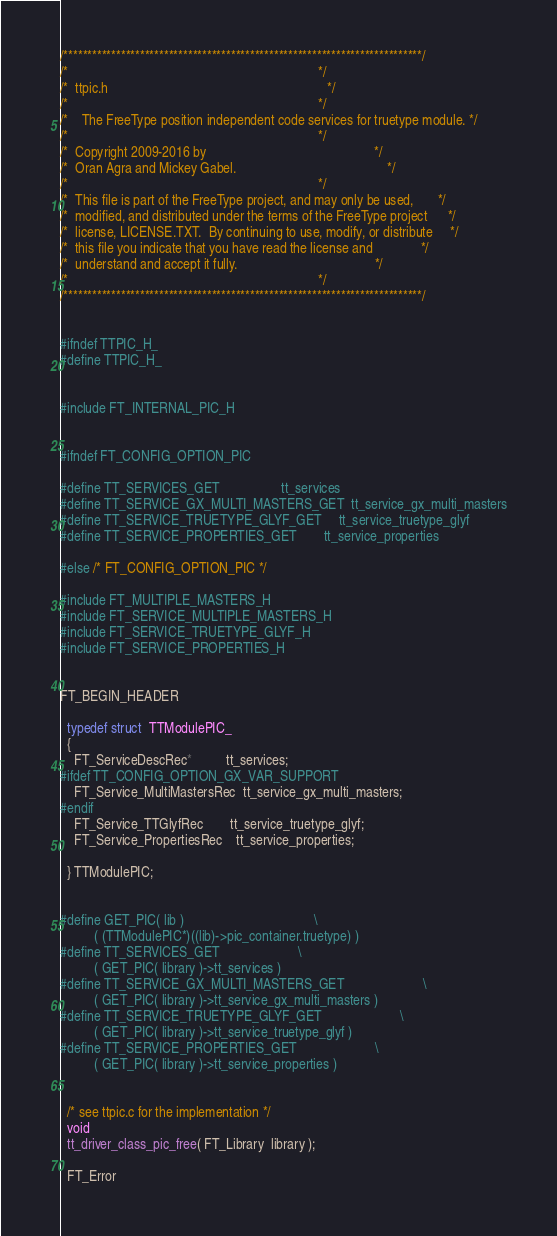<code> <loc_0><loc_0><loc_500><loc_500><_C_>/***************************************************************************/
/*                                                                         */
/*  ttpic.h                                                                */
/*                                                                         */
/*    The FreeType position independent code services for truetype module. */
/*                                                                         */
/*  Copyright 2009-2016 by                                                 */
/*  Oran Agra and Mickey Gabel.                                            */
/*                                                                         */
/*  This file is part of the FreeType project, and may only be used,       */
/*  modified, and distributed under the terms of the FreeType project      */
/*  license, LICENSE.TXT.  By continuing to use, modify, or distribute     */
/*  this file you indicate that you have read the license and              */
/*  understand and accept it fully.                                        */
/*                                                                         */
/***************************************************************************/


#ifndef TTPIC_H_
#define TTPIC_H_


#include FT_INTERNAL_PIC_H


#ifndef FT_CONFIG_OPTION_PIC

#define TT_SERVICES_GET                  tt_services
#define TT_SERVICE_GX_MULTI_MASTERS_GET  tt_service_gx_multi_masters
#define TT_SERVICE_TRUETYPE_GLYF_GET     tt_service_truetype_glyf
#define TT_SERVICE_PROPERTIES_GET        tt_service_properties

#else /* FT_CONFIG_OPTION_PIC */

#include FT_MULTIPLE_MASTERS_H
#include FT_SERVICE_MULTIPLE_MASTERS_H
#include FT_SERVICE_TRUETYPE_GLYF_H
#include FT_SERVICE_PROPERTIES_H


FT_BEGIN_HEADER

  typedef struct  TTModulePIC_
  {
    FT_ServiceDescRec*          tt_services;
#ifdef TT_CONFIG_OPTION_GX_VAR_SUPPORT
    FT_Service_MultiMastersRec  tt_service_gx_multi_masters;
#endif
    FT_Service_TTGlyfRec        tt_service_truetype_glyf;
    FT_Service_PropertiesRec    tt_service_properties;

  } TTModulePIC;


#define GET_PIC( lib )                                      \
          ( (TTModulePIC*)((lib)->pic_container.truetype) )
#define TT_SERVICES_GET                       \
          ( GET_PIC( library )->tt_services )
#define TT_SERVICE_GX_MULTI_MASTERS_GET                       \
          ( GET_PIC( library )->tt_service_gx_multi_masters )
#define TT_SERVICE_TRUETYPE_GLYF_GET                       \
          ( GET_PIC( library )->tt_service_truetype_glyf )
#define TT_SERVICE_PROPERTIES_GET                       \
          ( GET_PIC( library )->tt_service_properties )


  /* see ttpic.c for the implementation */
  void
  tt_driver_class_pic_free( FT_Library  library );

  FT_Error</code> 